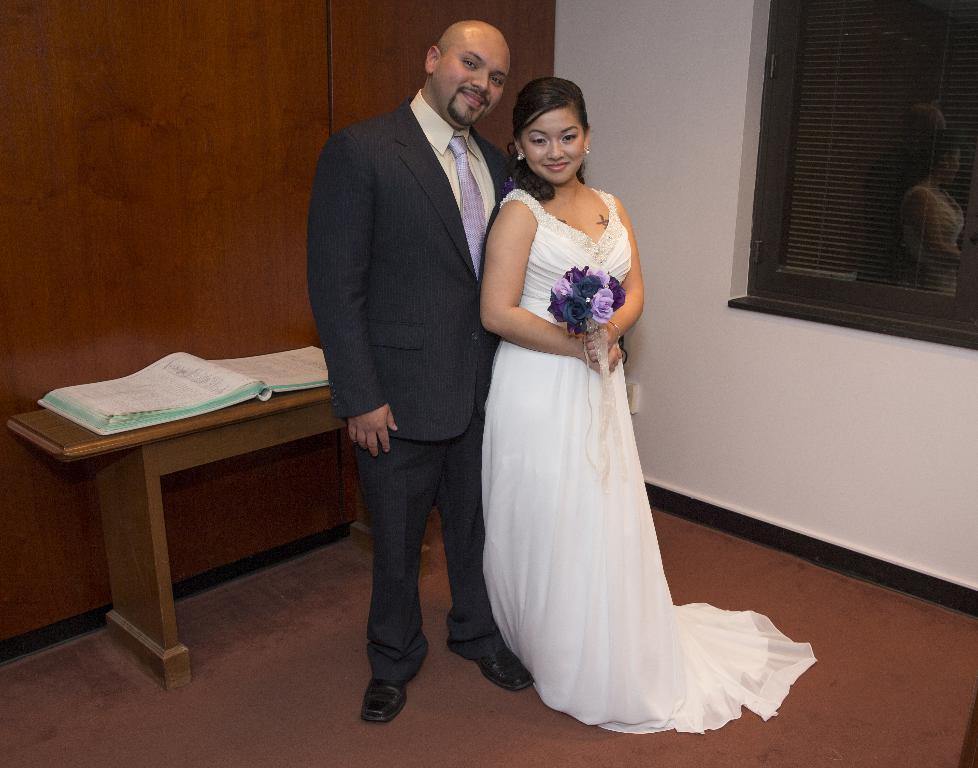Who are the people in the image? There is a man and a woman in the image. What are the man and woman doing in the image? The man and woman are standing and smiling. What is on the table in the image? There is a book on the table. What is the background of the image? There is a wall in the image, and there are windows with blinds. What type of music can be heard playing in the background of the image? There is no music present in the image, as it is a still photograph. How many units are visible in the image? The term "unit" is not mentioned in the provided facts, and therefore it cannot be determined from the image. 